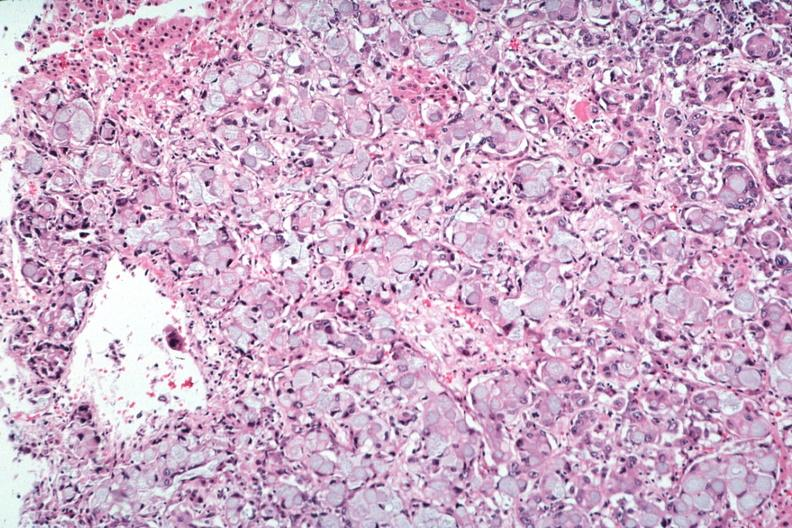s atrophy secondary to pituitectomy present?
Answer the question using a single word or phrase. No 